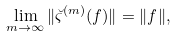<formula> <loc_0><loc_0><loc_500><loc_500>\lim _ { m \to \infty } \| \breve { \varsigma } ^ { ( m ) } ( f ) \| = \| f \| ,</formula> 